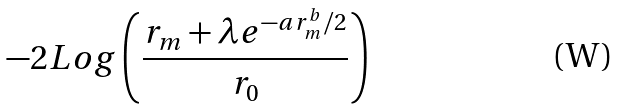<formula> <loc_0><loc_0><loc_500><loc_500>- 2 L o g \left ( \frac { r _ { m } + \lambda e ^ { - a r _ { m } ^ { b } / 2 } } { r _ { 0 } } \right )</formula> 